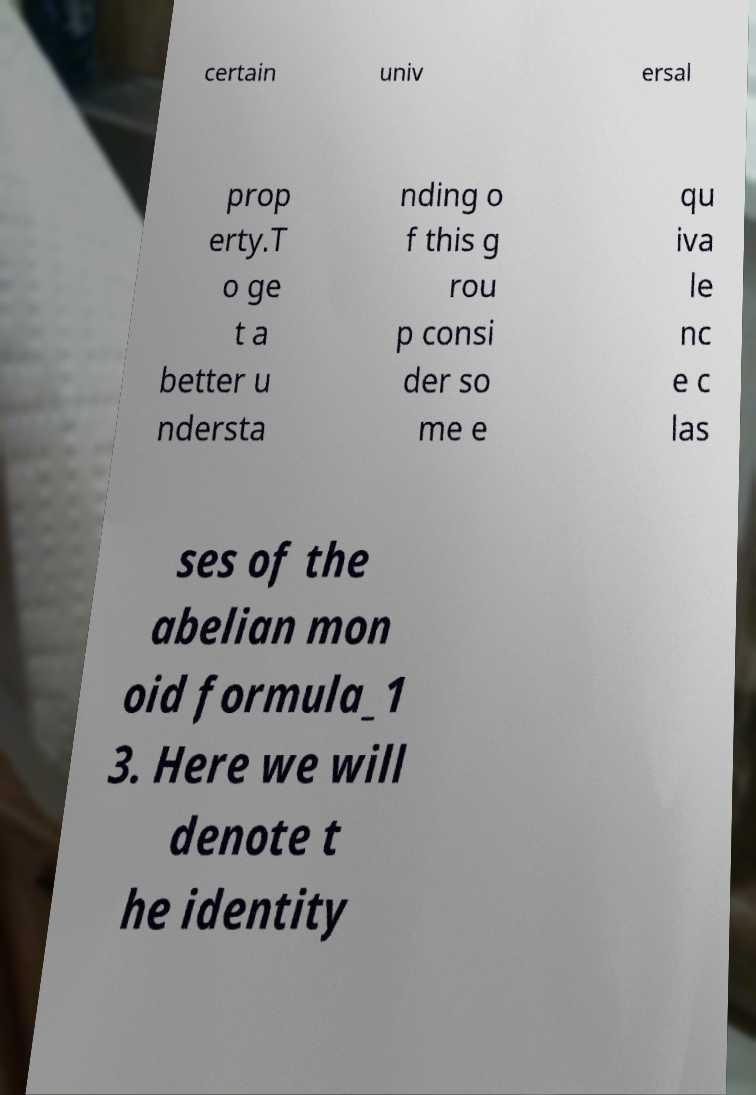Can you read and provide the text displayed in the image?This photo seems to have some interesting text. Can you extract and type it out for me? certain univ ersal prop erty.T o ge t a better u ndersta nding o f this g rou p consi der so me e qu iva le nc e c las ses of the abelian mon oid formula_1 3. Here we will denote t he identity 